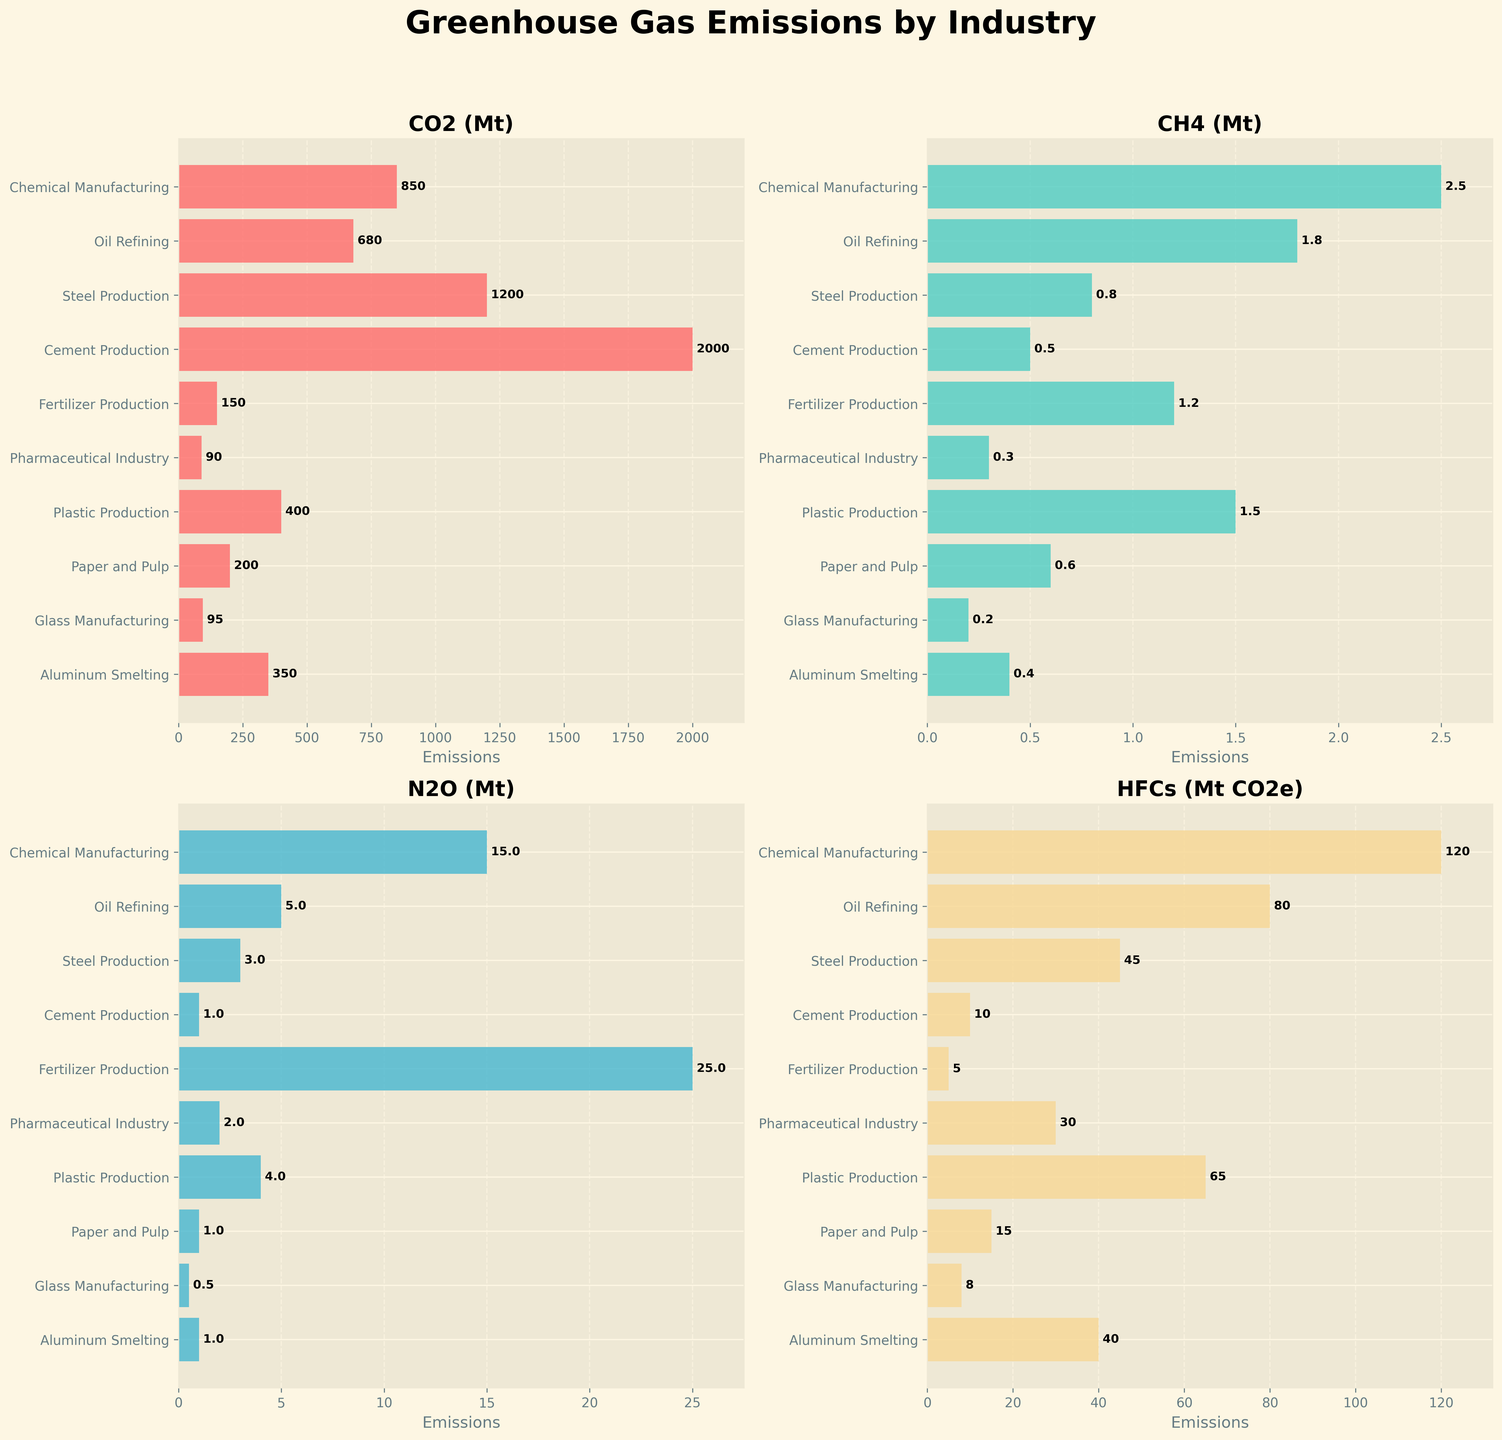What is the title of the figure? The title is usually displayed prominently at the top of the figure. In this case, it is "Greenhouse Gas Emissions by Industry," as indicated in the code under `fig.suptitle`.
Answer: Greenhouse Gas Emissions by Industry What industry has the highest CO2 emissions? The CO2 emissions are labeled in the first subplot with the title "CO2 (Mt)." By visually assessing the bar lengths, Cement Production has the highest bar, indicating the highest CO2 emissions.
Answer: Cement Production Which industry emits the least amount of CH4? The CH4 emissions are labeled in the second subplot with the title "CH4 (Mt)." By observing this subplot, Glass Manufacturing has the shortest bar, indicating it emits the least CH4.
Answer: Glass Manufacturing How do the CO2 emissions of Steel Production compare to those of Oil Refining? The first subplot shows CO2 emissions. The bar for Steel Production is longer than that for Oil Refining. This indicates that Steel Production has higher CO2 emissions than Oil Refining.
Answer: Steel Production has higher CO2 emissions than Oil Refining Which industry has the largest difference between N2O and CO2 emissions? We need to examine both the first and the third subplots. Fertilizer Production has 25 Mt of N2O and 150 Mt of CO2, resulting in a difference of 125 Mt. No other industry has a larger difference in magnitudes between these two gases.
Answer: Fertilizer Production What is the total CO2 emissions from Oil Refining and Plastic Production? The CO2 emissions for Oil Refining and Plastic Production are 680 Mt and 400 Mt respectively. Adding these together, 680 + 400 = 1080 Mt.
Answer: 1080 Mt How many industries emit over 1 Mt of N2O? Looking at the third subplot, the industries with bars above the 1 Mt mark are Chemical Manufacturing, Fertilizer Production, and Pharmaceutical Industry. There are 3 such industries.
Answer: 3 industries Which industry emits more HFCs: Pharmaceutical Industry or Aluminum Smelting? In the fourth subplot, we see that the Pharmaceutical Industry's bar is taller than that of Aluminum Smelting. This means Pharmaceutical Industry emits more HFCs.
Answer: Pharmaceutical Industry What industry has the closest CH4 emissions to those of Plastic Production? Referring to the second subplot, Plastic Production has a CH4 emission of 1.5 Mt. The closest other industry in terms of CH4 emissions is Oil Refining with 1.8 Mt.
Answer: Oil Refining What is the range of CO2 emissions across all industries? The range is calculated by subtracting the smallest value from the largest value. The smallest CO2 emission is Glass Manufacturing with 95 Mt, and the largest is Cement Production with 2000 Mt. Thus, the range is 2000 - 95 = 1905 Mt.
Answer: 1905 Mt 